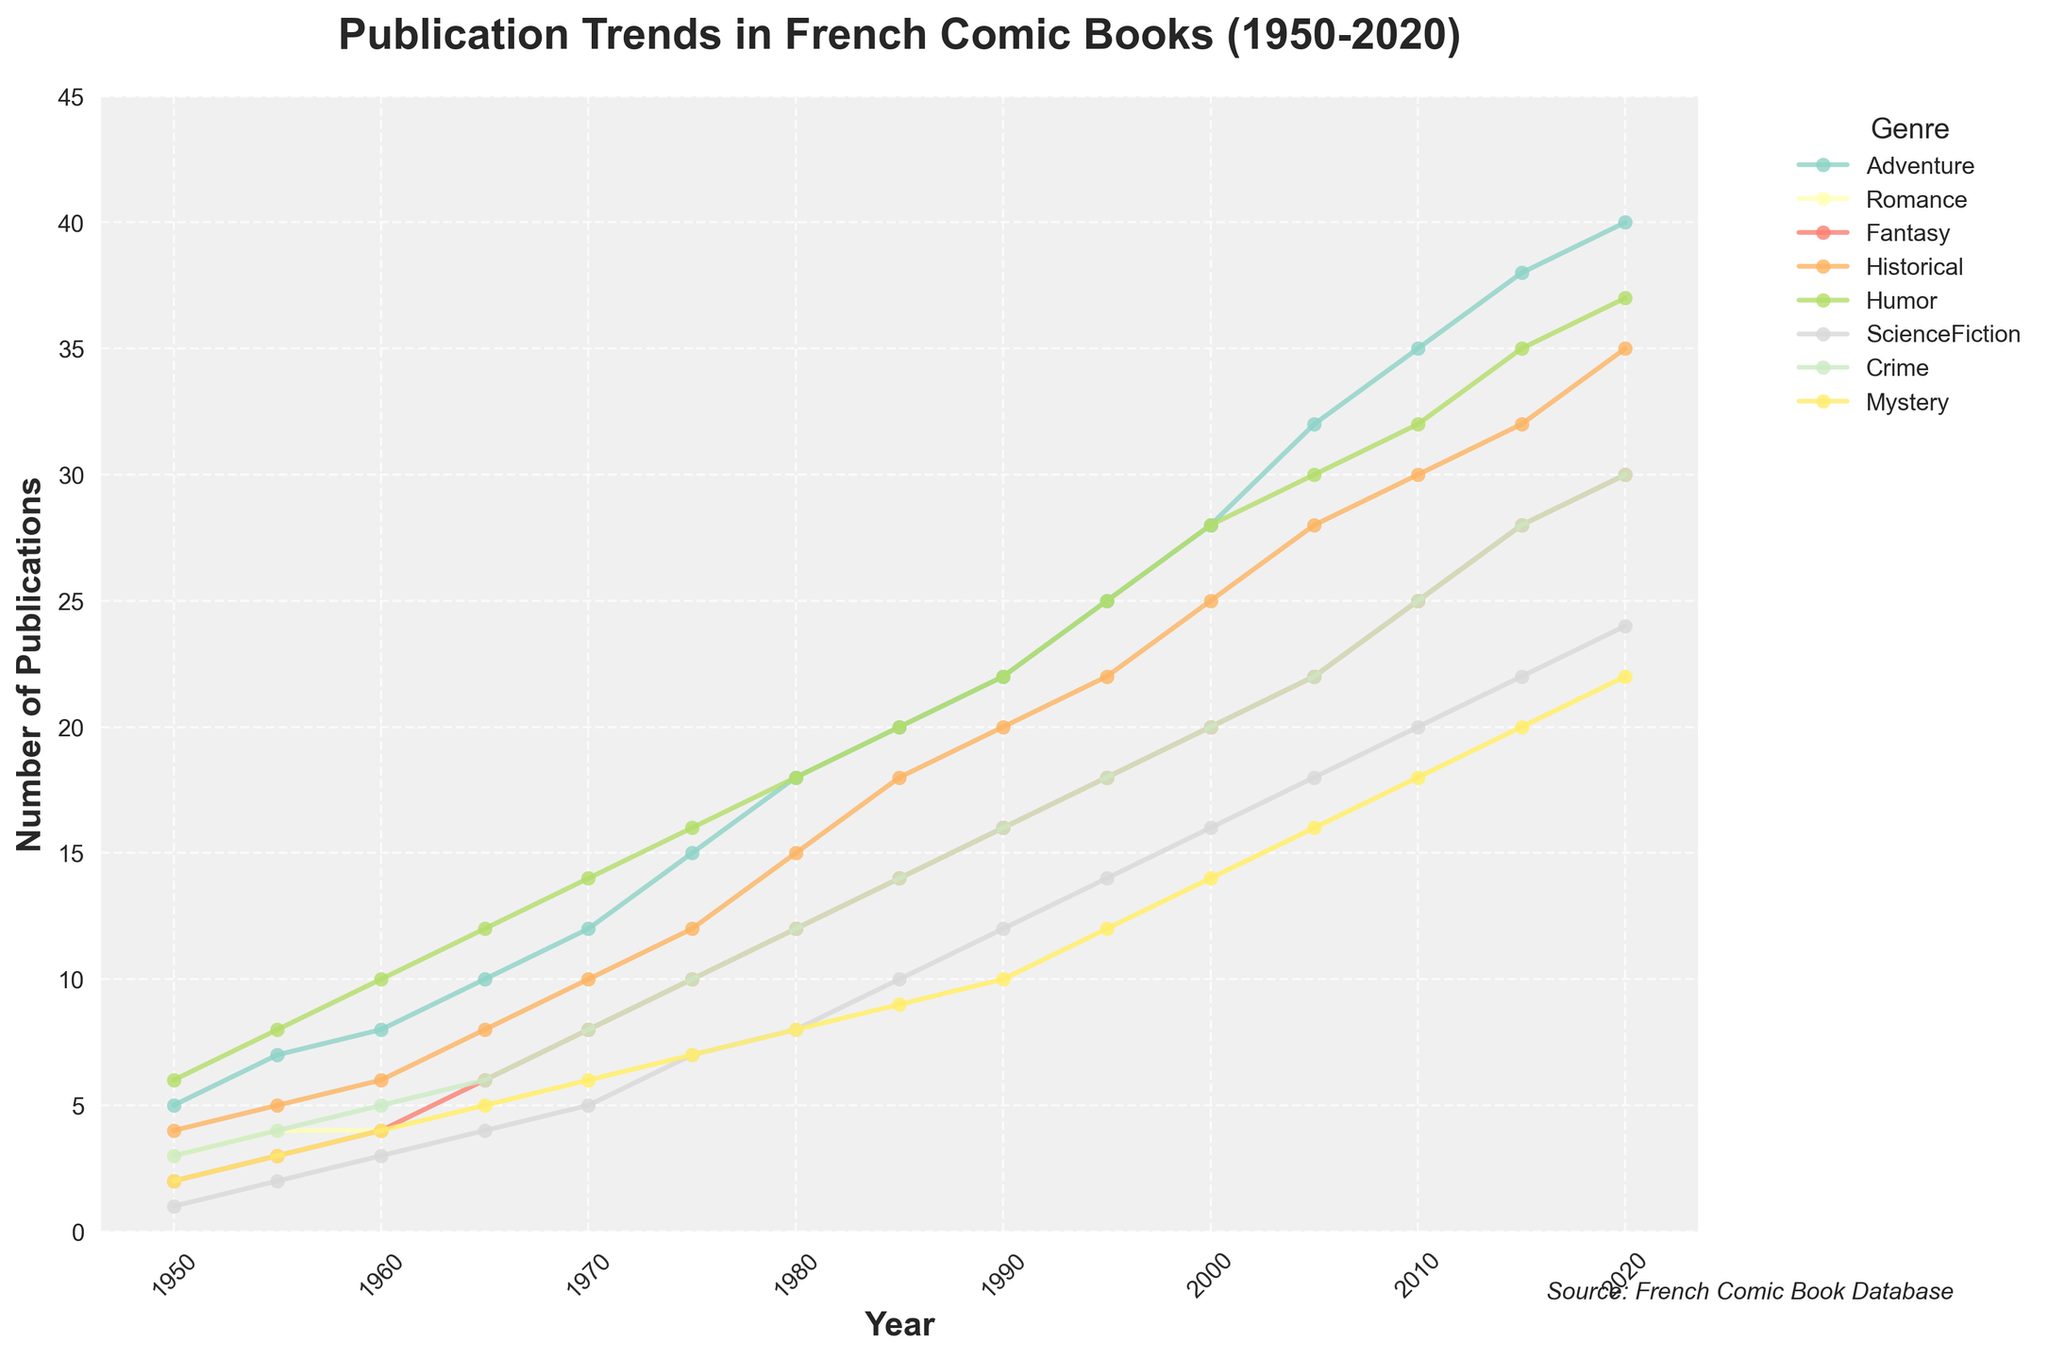What is the title of the plot? The title of the plot is displayed at the top-center of the figure, which summarizes what the plot is about.
Answer: Publication Trends in French Comic Books (1950-2020) Which genre had the highest number of publications in 2020? In 2020, we can scan the y-axis to find the highest point for each genre. The highest point corresponds to humor.
Answer: Humor How did the number of Romance publications change from 1950 to 2020? We can look at the line corresponding to the Romance genre and observe the trend. It starts at 3 in 1950 and goes up to 22 in 2020.
Answer: Increased Which genre saw the most significant increase in publications between 1970 and 2020? Calculating the difference in the number of publications between 1970 and 2020 for each genre, Humor (37 - 14 = 23) shows the most significant increase.
Answer: Humor What is the overall trend for Science Fiction publications from 1950 to 2020? Observing the Science Fiction genre, we see a consistent upward trend starting from 1 publication in 1950 and increasing to 24 in 2020.
Answer: Upward Trend In which year does Adventure surpass Fantasy in the number of publications? By comparing the Adventure and Fantasy lines across the timeline, Adventure surpasses Fantasy in around 1965.
Answer: 1965 What is the average number of Crime publications in 1990 and 2000? Summing the values for 1990 (16) and 2000 (20), we get 36. Dividing this by 2 gives an average.
Answer: 18 Compare the publication trends of Historical and Mystery genres from 1980 to 2000. From 1980 to 2000, both genres show an upward trend. Historical starts at 15 and ends at 25, while Mystery starts at 8 and ends at 14.
Answer: Both Increased In which decade did the Fantasy genre see the most growth? We calculate the decade-wise differences between consecutive values. The Fantasy genre saw the highest growth in the decade between 1950 (2) and 1960 (4) with a change of 2.
Answer: 1950s What is the median number of publications for the Humor genre from 1950 to 2020? Arranging the values for the Humor genre in ascending order: [6, 8, 10, 12, 14, 16, 18, 20, 22, 25, 28, 30, 32, 35, 37], the median (middle value) is 18.
Answer: 18 